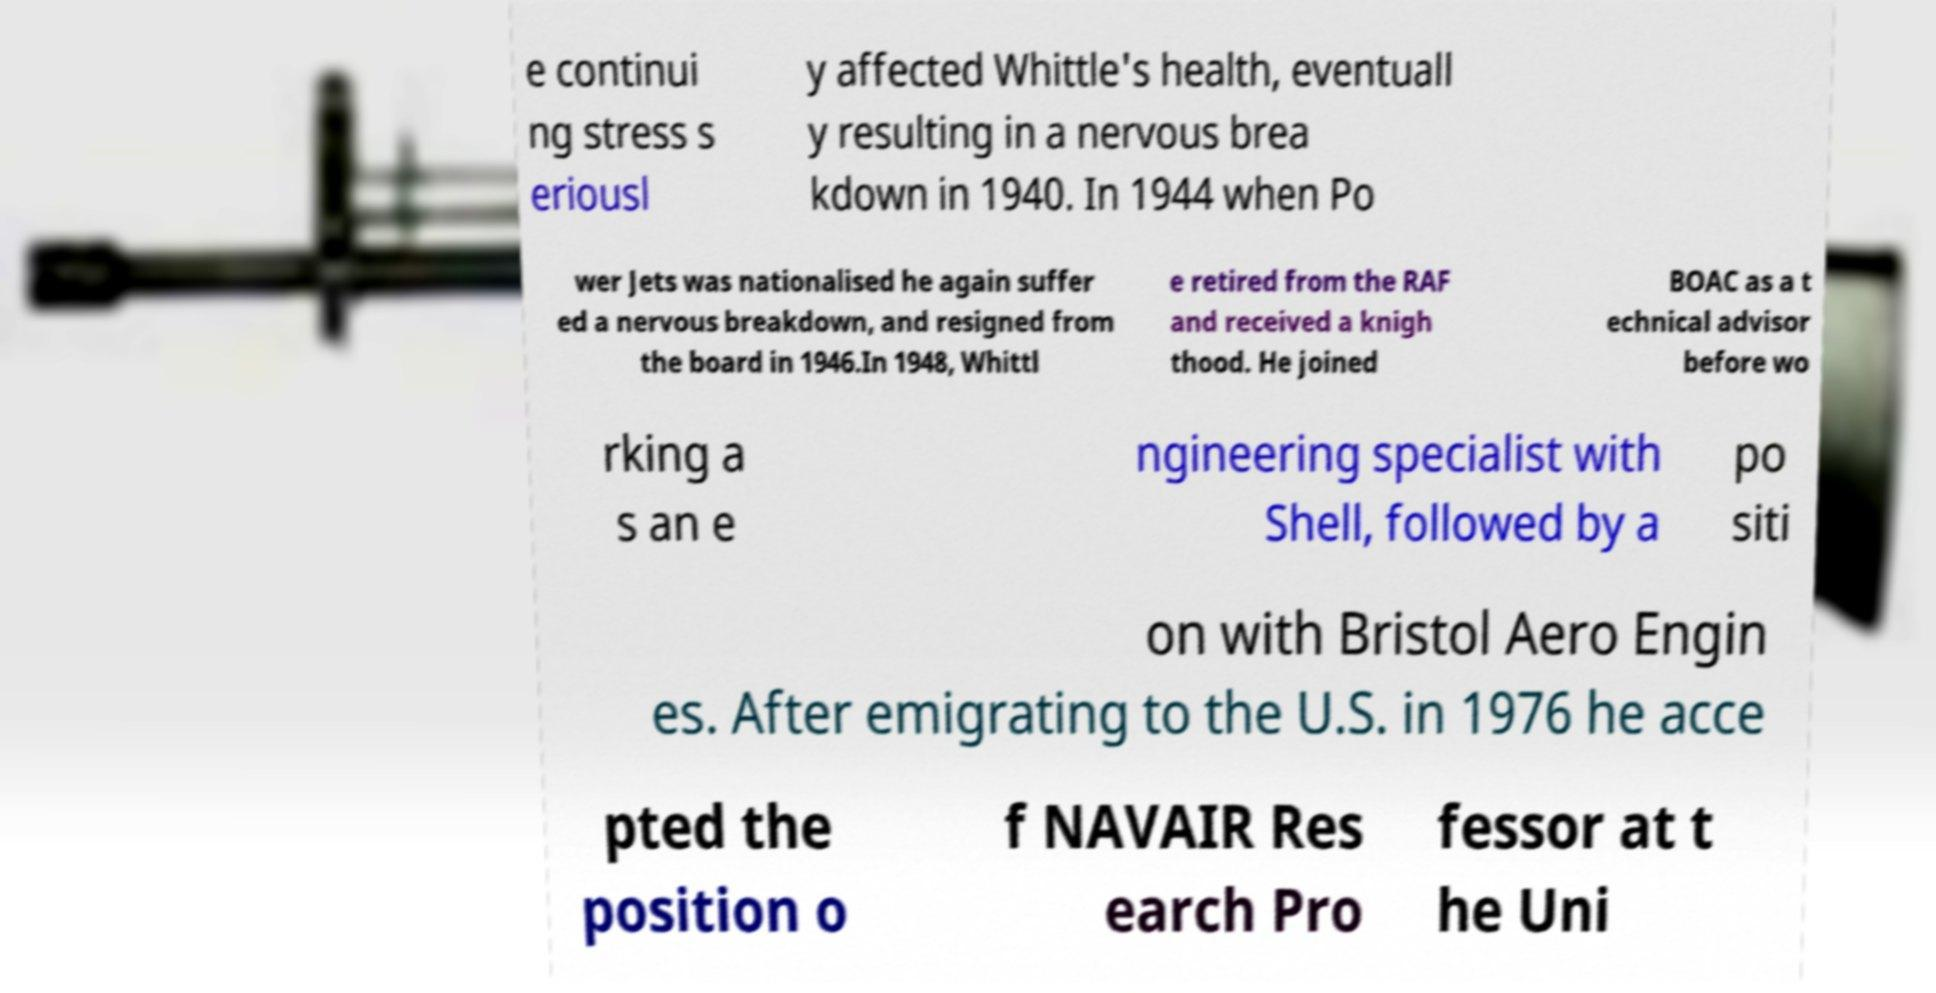Could you extract and type out the text from this image? e continui ng stress s eriousl y affected Whittle's health, eventuall y resulting in a nervous brea kdown in 1940. In 1944 when Po wer Jets was nationalised he again suffer ed a nervous breakdown, and resigned from the board in 1946.In 1948, Whittl e retired from the RAF and received a knigh thood. He joined BOAC as a t echnical advisor before wo rking a s an e ngineering specialist with Shell, followed by a po siti on with Bristol Aero Engin es. After emigrating to the U.S. in 1976 he acce pted the position o f NAVAIR Res earch Pro fessor at t he Uni 